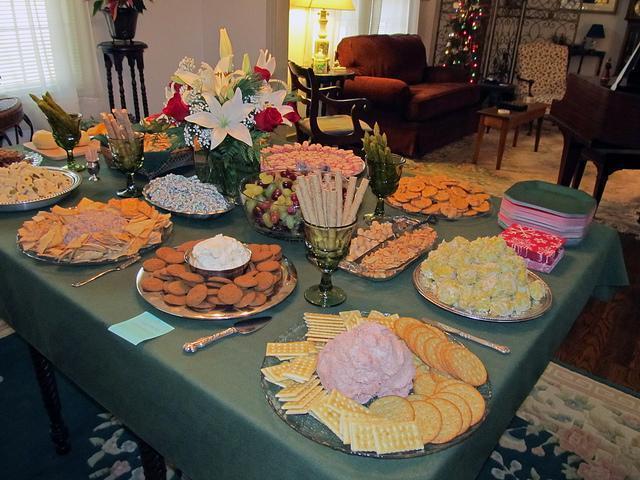How many chairs can you see?
Give a very brief answer. 3. How many bowls can be seen?
Give a very brief answer. 2. 